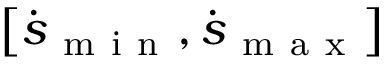<formula> <loc_0><loc_0><loc_500><loc_500>\left [ \dot { s } _ { m i n } , \dot { s } _ { m a x } \right ]</formula> 